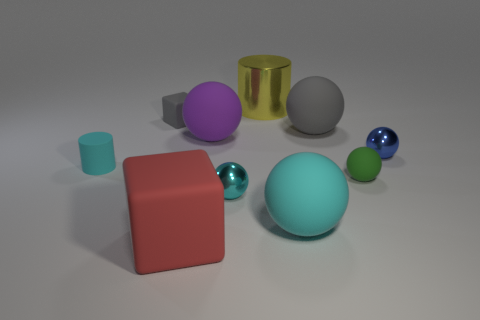What is the size of the cylinder in front of the matte cube behind the thing in front of the big cyan matte ball?
Offer a very short reply. Small. Is the cyan ball to the left of the yellow metallic cylinder made of the same material as the gray cube?
Provide a short and direct response. No. There is a object that is the same color as the small matte block; what is its material?
Make the answer very short. Rubber. Are there any other things that are the same shape as the big red matte thing?
Ensure brevity in your answer.  Yes. How many objects are either cyan spheres or rubber spheres?
Offer a very short reply. 5. What is the size of the yellow thing that is the same shape as the tiny cyan matte thing?
Ensure brevity in your answer.  Large. How many other objects are the same color as the tiny matte cylinder?
Offer a terse response. 2. How many blocks are either big purple things or small green rubber things?
Offer a very short reply. 0. The metal sphere to the right of the cylinder on the right side of the large red object is what color?
Give a very brief answer. Blue. There is a tiny green object; what shape is it?
Provide a succinct answer. Sphere. 